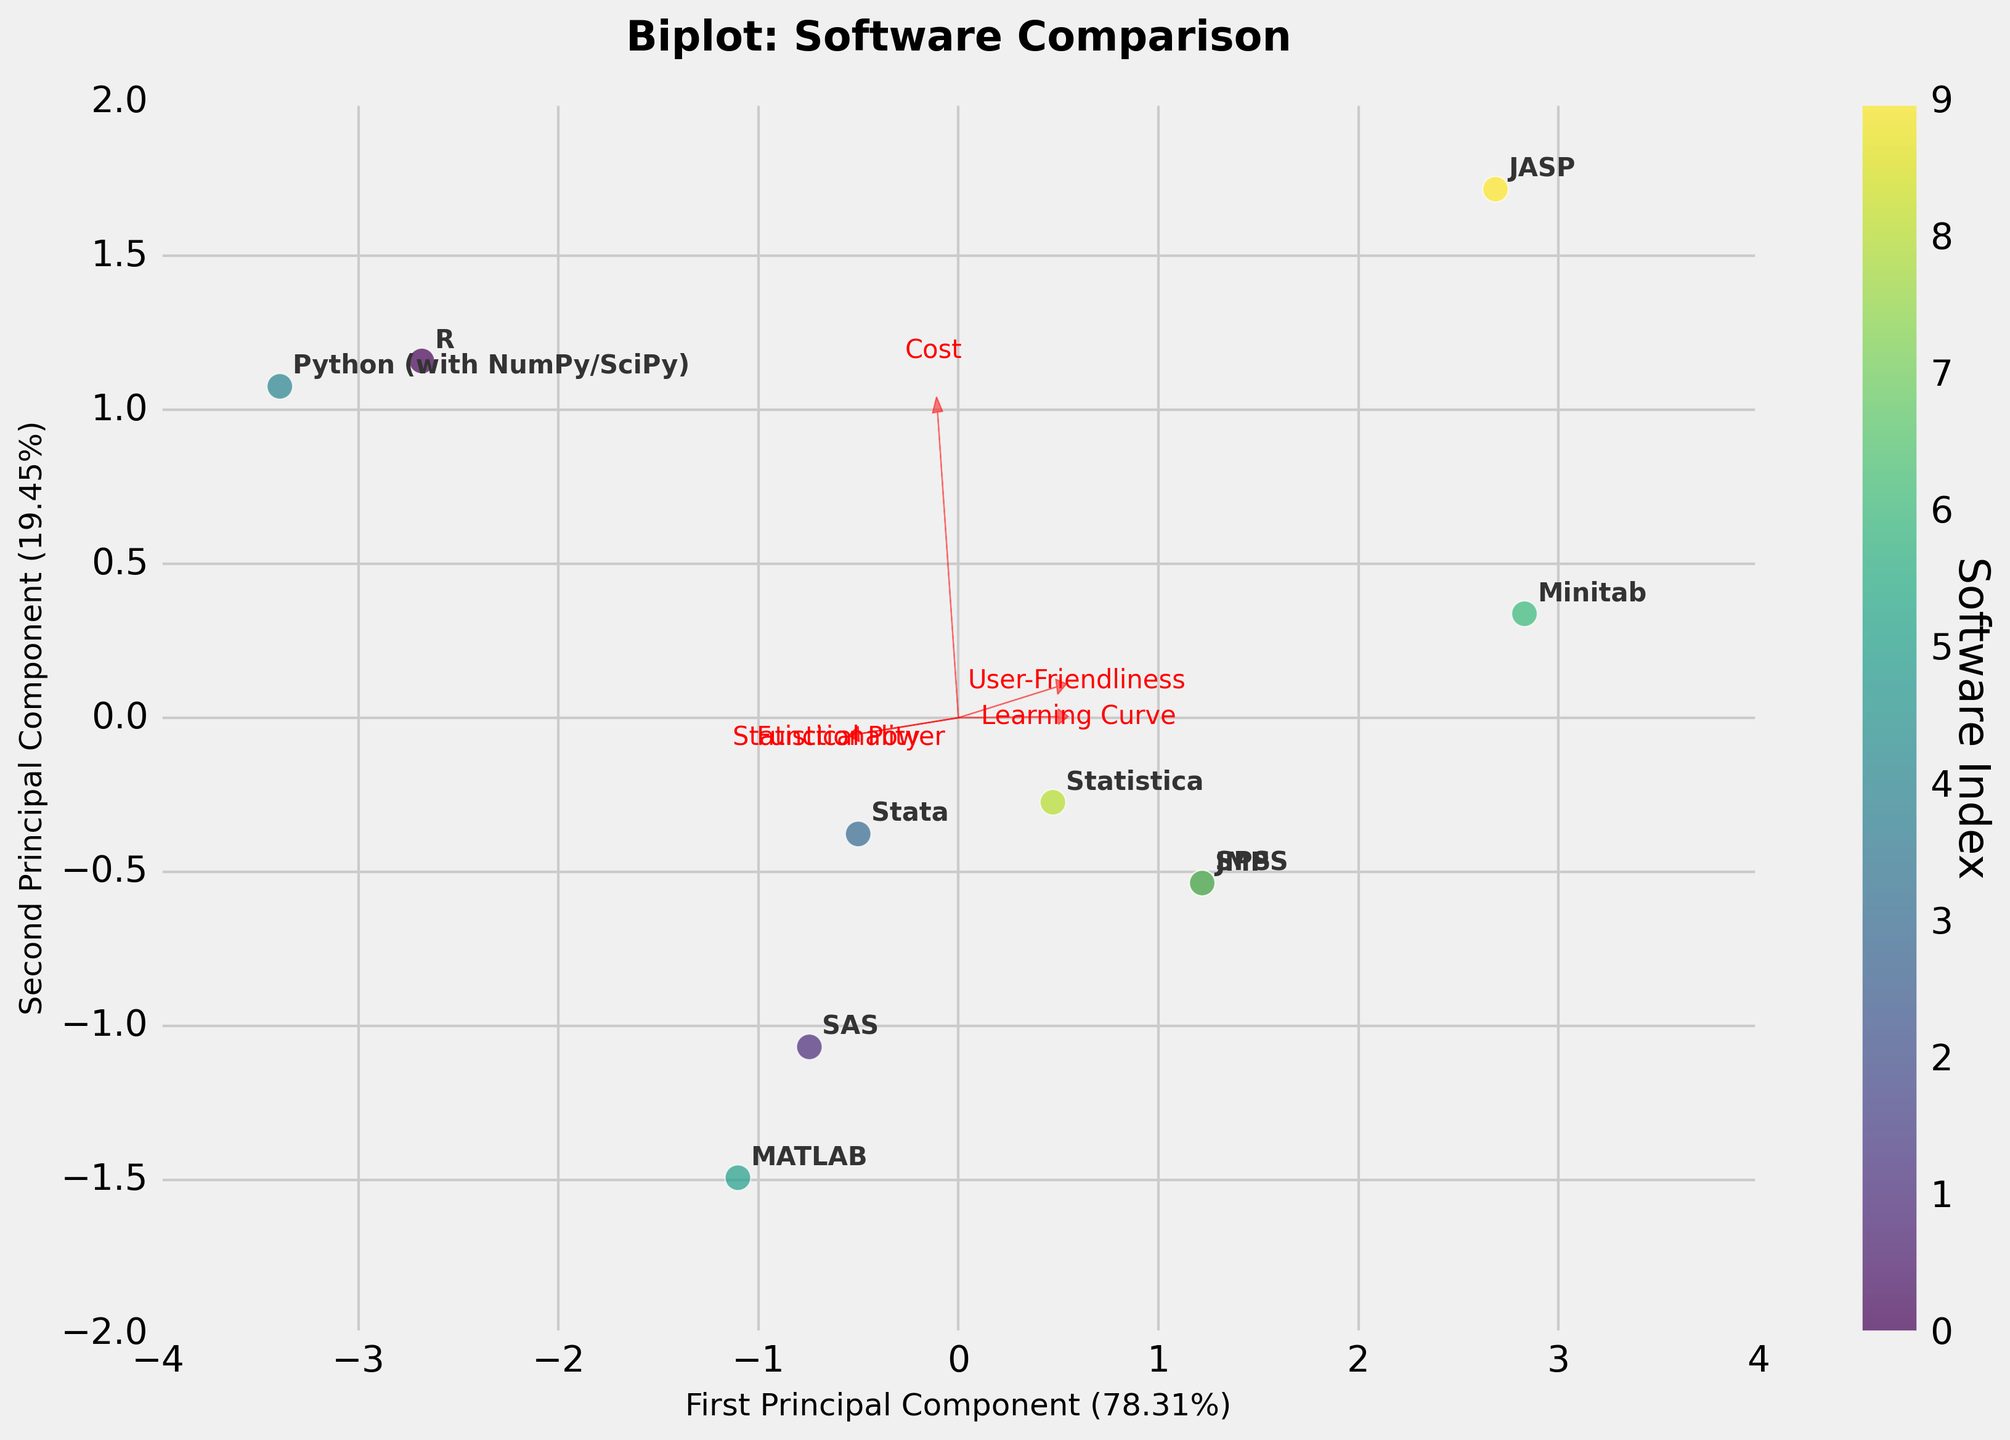Which software package is located at the rightmost position on the plot? The rightmost software package on the biplot indicates the highest value on the first principal component axis, which is R.
Answer: R Which feature vector is pointing closest to the upper right quadrant of the biplot? The feature vectors are arrows labeled with the feature names. The vector pointing closest to the upper right quadrant indicates high values on both principal components, and in this case, it is labeled "Statistical Power."
Answer: Statistical Power Which software package appears closest to the origin of the biplot? The software package near the origin of the biplot suggests moderate scores on both principal components. In this case, it is SPSS.
Answer: SPSS How many principal components are represented in the biplot? The biplot shows two axes representing two principal components.
Answer: 2 What is the title of the plot? The title of the plot is displayed at the top center. It reads "Biplot: Software Comparison."
Answer: Biplot: Software Comparison Among the software packages, which one is shown to have the highest user-friendliness based on the feature vector direction? By following the direction of the "User-Friendliness" vector, the software package closest to it indicates the highest user-friendliness. In this case, it is Minitab and JASP.
Answer: Minitab and JASP Which software packages score similarly on the first and second principal components and are located close to each other? The software packages clustered together on the biplot indicate similar scores. SPSS and JMP are located close to each other in the plot, suggesting similar scores.
Answer: SPSS and JMP Which software package seems to have a high statistical power but a lower user-friendliness? Software packages pointing along the "Statistical Power" vector with lower "User-Friendliness" values can be identified. Python with NumPy/SciPy is one such software.
Answer: Python (with NumPy/SciPy) On which principal component does the majority of the total variance seem to be explained, based on the explained variance ratios shown on the axes labels? The explained variance ratios are shown in the labels of the axes, with the first principal component explaining more variance (highest percentage indicated).
Answer: First Principal Component 